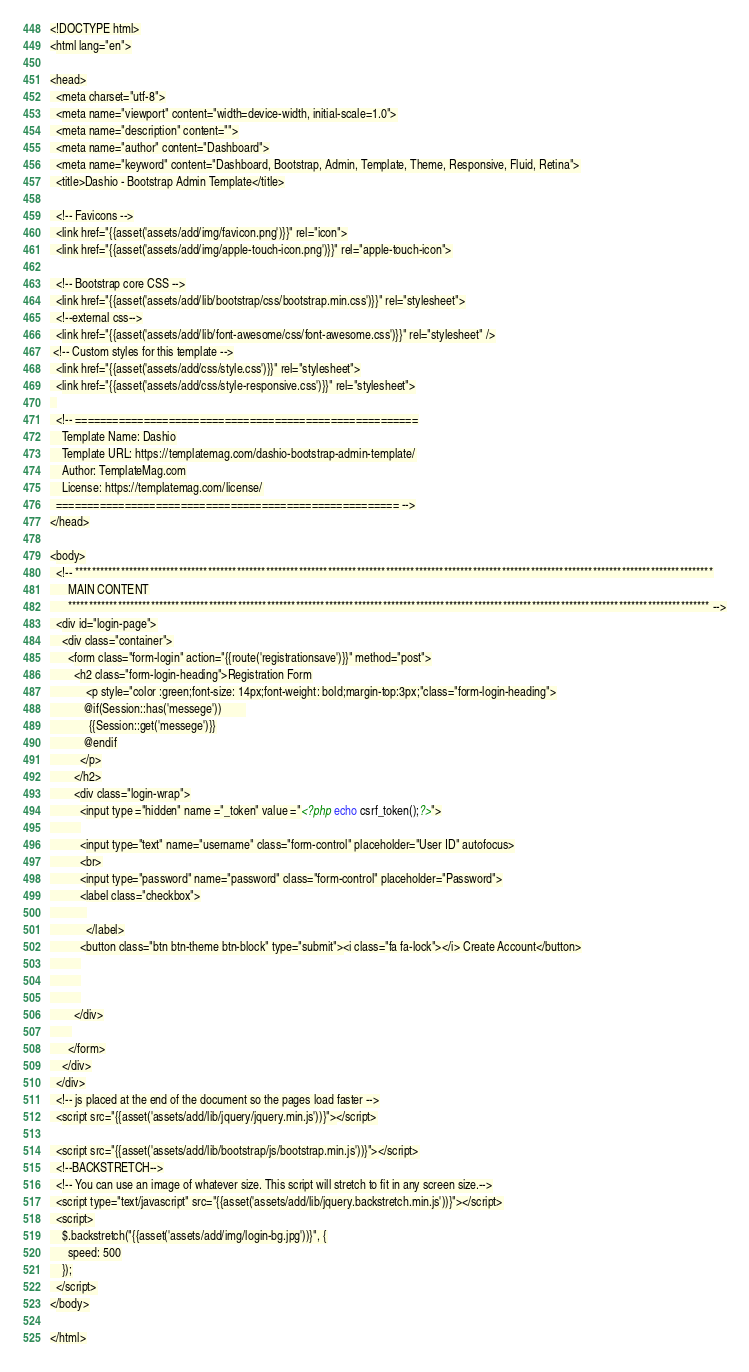<code> <loc_0><loc_0><loc_500><loc_500><_PHP_><!DOCTYPE html>
<html lang="en">

<head>
  <meta charset="utf-8">
  <meta name="viewport" content="width=device-width, initial-scale=1.0">
  <meta name="description" content="">
  <meta name="author" content="Dashboard">
  <meta name="keyword" content="Dashboard, Bootstrap, Admin, Template, Theme, Responsive, Fluid, Retina">
  <title>Dashio - Bootstrap Admin Template</title>

  <!-- Favicons -->
  <link href="{{asset('assets/add/img/favicon.png')}}" rel="icon">
  <link href="{{asset('assets/add/img/apple-touch-icon.png')}}" rel="apple-touch-icon">

  <!-- Bootstrap core CSS -->
  <link href="{{asset('assets/add/lib/bootstrap/css/bootstrap.min.css')}}" rel="stylesheet">
  <!--external css-->
  <link href="{{asset('assets/add/lib/font-awesome/css/font-awesome.css')}}" rel="stylesheet" />
 <!-- Custom styles for this template -->
  <link href="{{asset('assets/add/css/style.css')}}" rel="stylesheet">
  <link href="{{asset('assets/add/css/style-responsive.css')}}" rel="stylesheet">
  
  <!-- =======================================================
    Template Name: Dashio
    Template URL: https://templatemag.com/dashio-bootstrap-admin-template/
    Author: TemplateMag.com
    License: https://templatemag.com/license/
  ======================================================= -->
</head>

<body>
  <!-- **********************************************************************************************************************************************************
      MAIN CONTENT
      *********************************************************************************************************************************************************** -->
  <div id="login-page">
    <div class="container">
      <form class="form-login" action="{{route('registrationsave')}}" method="post">
        <h2 class="form-login-heading">Registration Form
            <p style="color :green;font-size: 14px;font-weight: bold;margin-top:3px;"class="form-login-heading">
           @if(Session::has('messege'))        
             {{Session::get('messege')}}
           @endif
          </p>
        </h2>
        <div class="login-wrap">
          <input type ="hidden" name ="_token" value ="<?php echo csrf_token();?>">
          
          <input type="text" name="username" class="form-control" placeholder="User ID" autofocus>
          <br>
          <input type="password" name="password" class="form-control" placeholder="Password">
          <label class="checkbox">
            
            </label>
          <button class="btn btn-theme btn-block" type="submit"><i class="fa fa-lock"></i> Create Account</button>
          
          
          
        </div>
       
      </form>
    </div>
  </div>
  <!-- js placed at the end of the document so the pages load faster -->
  <script src="{{asset('assets/add/lib/jquery/jquery.min.js'))}"></script>

  <script src="{{asset('assets/add/lib/bootstrap/js/bootstrap.min.js'))}"></script>
  <!--BACKSTRETCH-->
  <!-- You can use an image of whatever size. This script will stretch to fit in any screen size.-->
  <script type="text/javascript" src="{{asset('assets/add/lib/jquery.backstretch.min.js'))}"></script>
  <script>
    $.backstretch("{{asset('assets/add/img/login-bg.jpg'))}", {
      speed: 500
    });
  </script>
</body>

</html>
</code> 